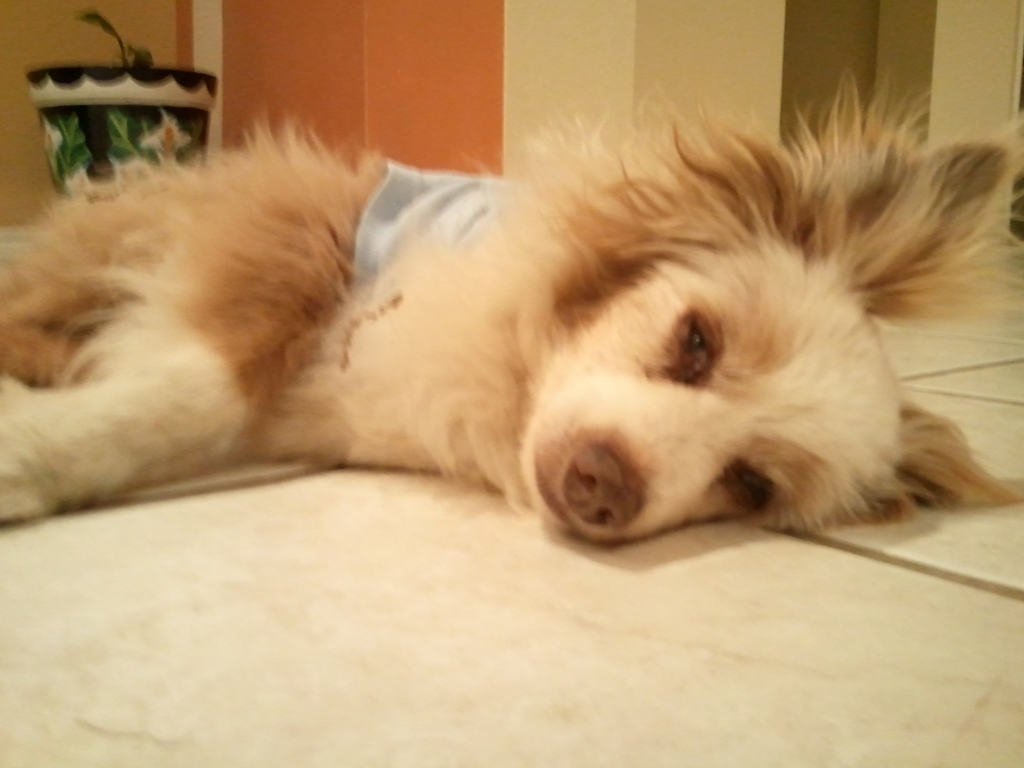What details in the image suggest that the dog may be resting? The dog's relaxed pose, with its head resting on the ground and eyes partially closed, indicates a state of rest. Additionally, the dog's body is settled comfortably on the floor, with no signs of tension suggesting movement or alertness, which further implies that the dog is in a resting position. Can you tell what time of day it might be when this photo was taken? Although it's not possible to determine the exact time of day with certainty, the indoor lighting and absence of natural sunlight coming through any visible windows suggest it could be the evening or a time when daylight is not prominent. 